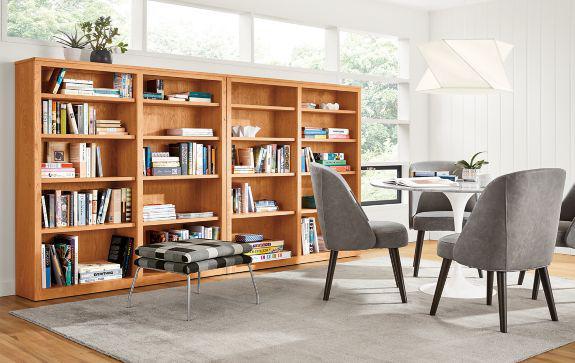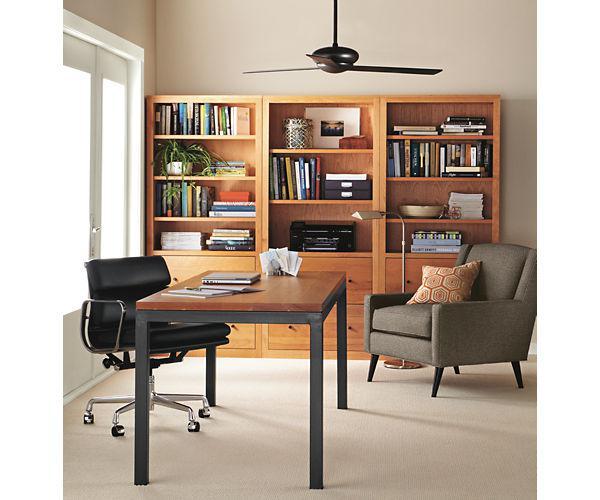The first image is the image on the left, the second image is the image on the right. Given the left and right images, does the statement "A TV is sitting on a stand between two bookshelves." hold true? Answer yes or no. No. The first image is the image on the left, the second image is the image on the right. Examine the images to the left and right. Is the description "There is a television set in between two bookcases." accurate? Answer yes or no. No. 